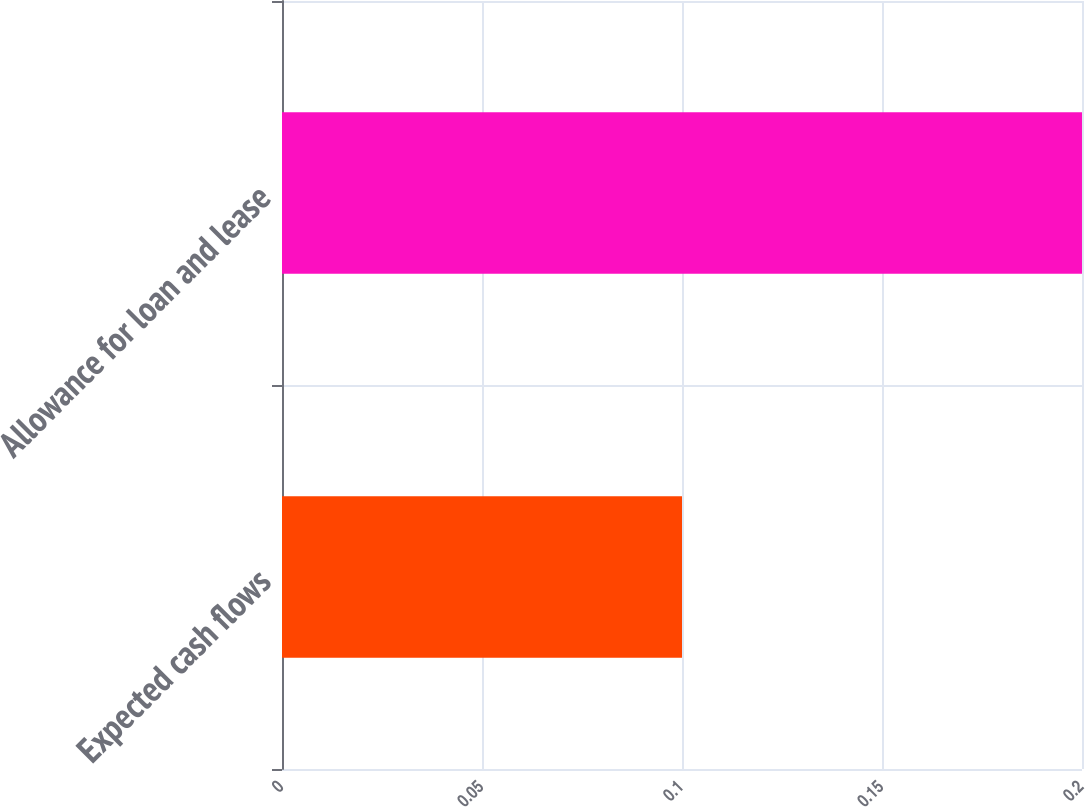Convert chart to OTSL. <chart><loc_0><loc_0><loc_500><loc_500><bar_chart><fcel>Expected cash flows<fcel>Allowance for loan and lease<nl><fcel>0.1<fcel>0.2<nl></chart> 